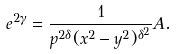Convert formula to latex. <formula><loc_0><loc_0><loc_500><loc_500>e ^ { 2 \gamma } = \frac { 1 } { p ^ { 2 \delta } ( x ^ { 2 } - y ^ { 2 } ) ^ { \delta ^ { 2 } } } A .</formula> 